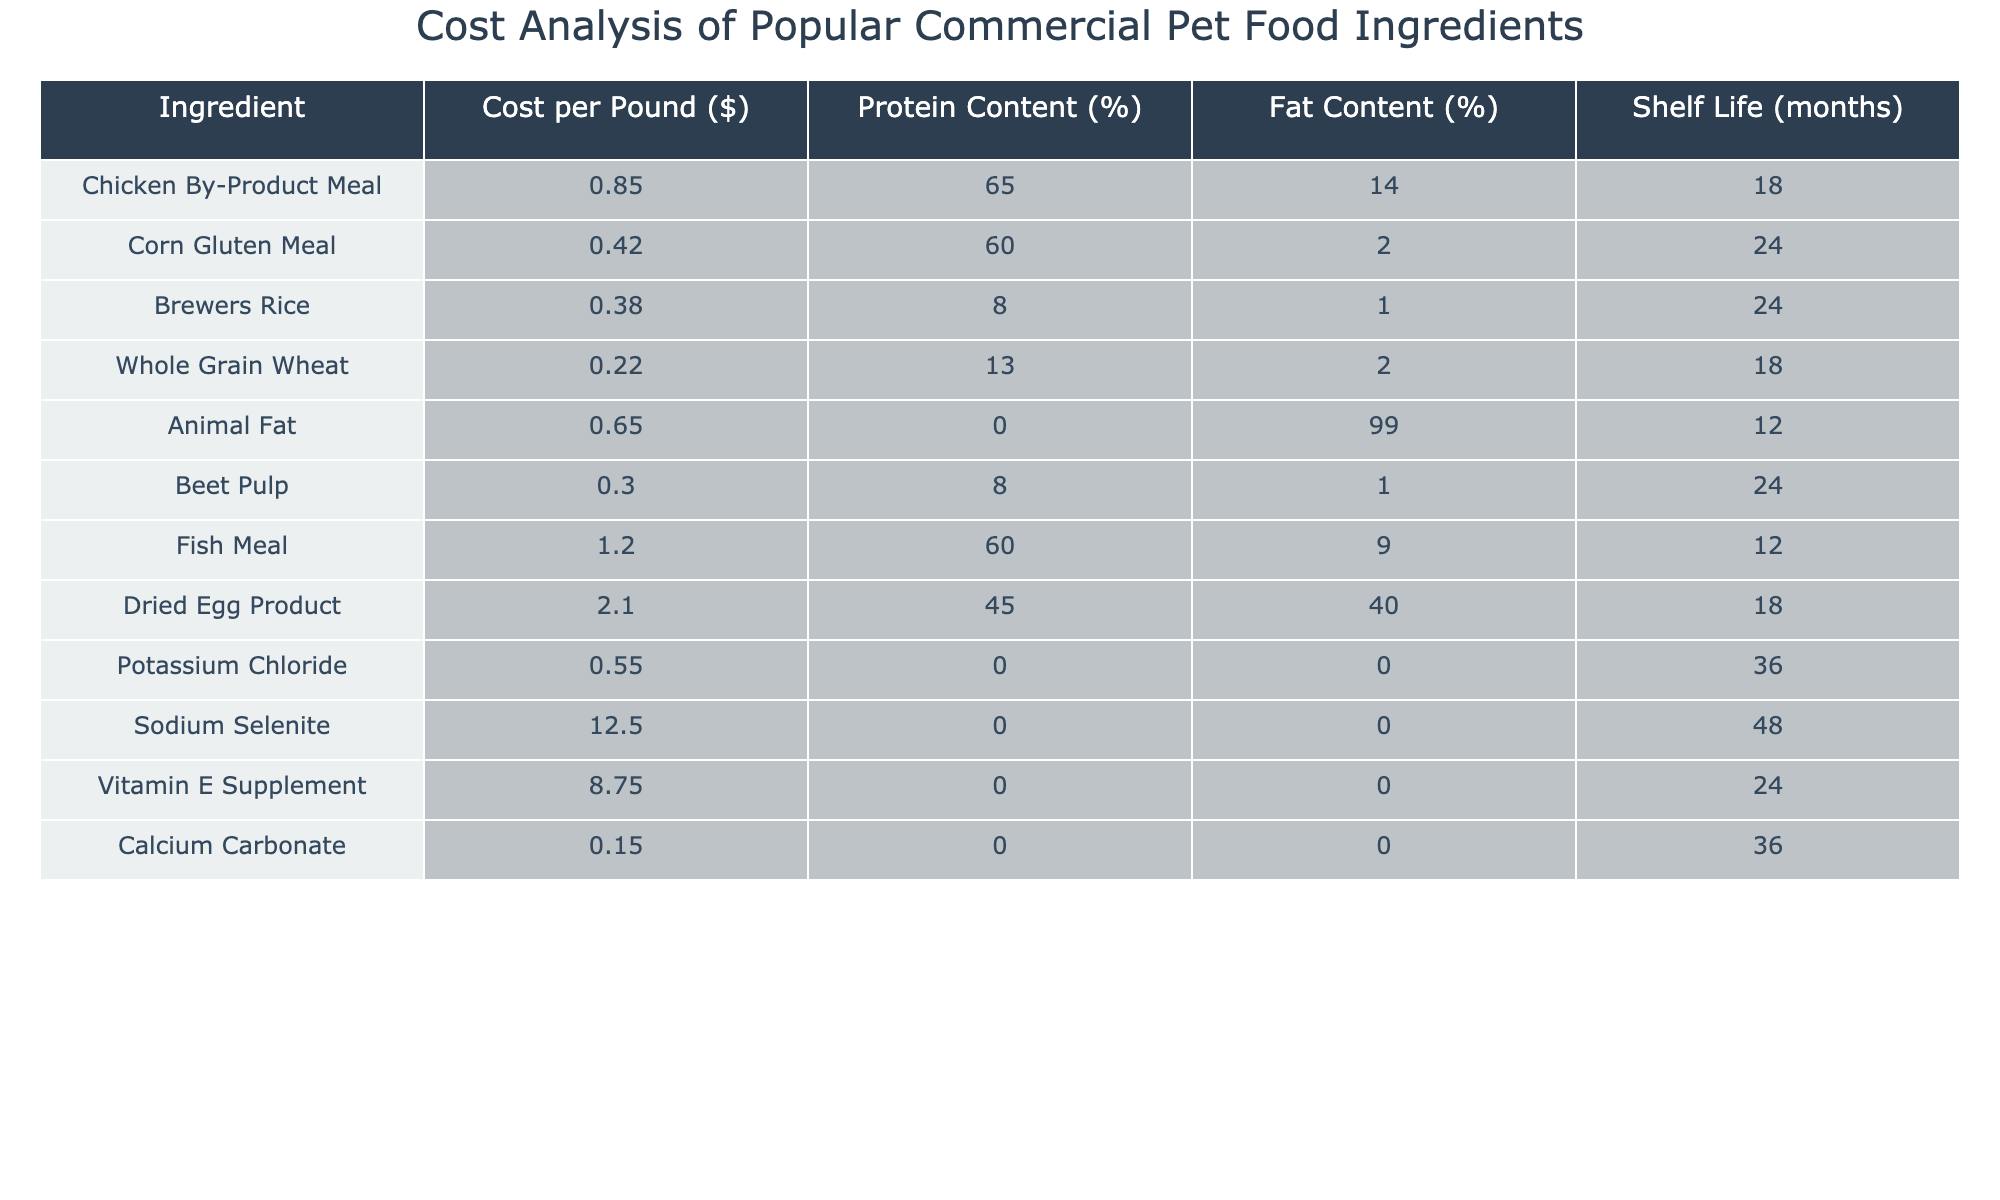What is the cost per pound of Fish Meal? The table indicates that Fish Meal has a cost per pound listed as $1.20.
Answer: $1.20 Which ingredient has the highest protein content? By scanning through the protein content percentages, Chicken By-Product Meal has the highest at 65%.
Answer: Chicken By-Product Meal How many months is the shelf life of Corn Gluten Meal? Corn Gluten Meal has a shelf life of 24 months as seen in the table.
Answer: 24 months What is the total cost per pound of the top three most expensive ingredients? The three most expensive ingredients are Dried Egg Product ($2.10), Fish Meal ($1.20), and Sodium Selenite ($12.50). Adding these gives $2.10 + $1.20 + $12.50 = $15.80.
Answer: $15.80 Does Animal Fat have any protein content? Animal Fat has a protein content percentage of 0%, as noted in the table.
Answer: No Which ingredient has the lowest fat content? The ingredient with the lowest fat content, which is also observable, is Brewers Rice at 1%.
Answer: Brewers Rice What is the average protein content of the listed ingredients? Calculating the average involves adding the protein contents (65 + 60 + 8 + 13 + 0 + 8 + 60 + 45 + 0 + 0 + 0 = 259) and dividing by the number of ingredients (11). Therefore, 259/11 = 23.545.
Answer: 23.55% How many ingredients have a shelf life of 24 months? A quick look reveals that Corn Gluten Meal, Brewers Rice, and Beet Pulp each have a shelf life of 24 months, totaling three ingredients.
Answer: 3 Is the cost per pound of Potassium Chloride higher than that of Calcium Carbonate? Potassium Chloride costs $0.55 per pound while Calcium Carbonate costs $0.15; thus, Potassium Chloride is higher.
Answer: Yes What is the difference in price per pound between the most expensive and least expensive ingredient? The most expensive ingredient is Sodium Selenite at $12.50 while the least expensive ingredient is Calcium Carbonate at $0.15. The difference is $12.50 - $0.15 = $12.35.
Answer: $12.35 